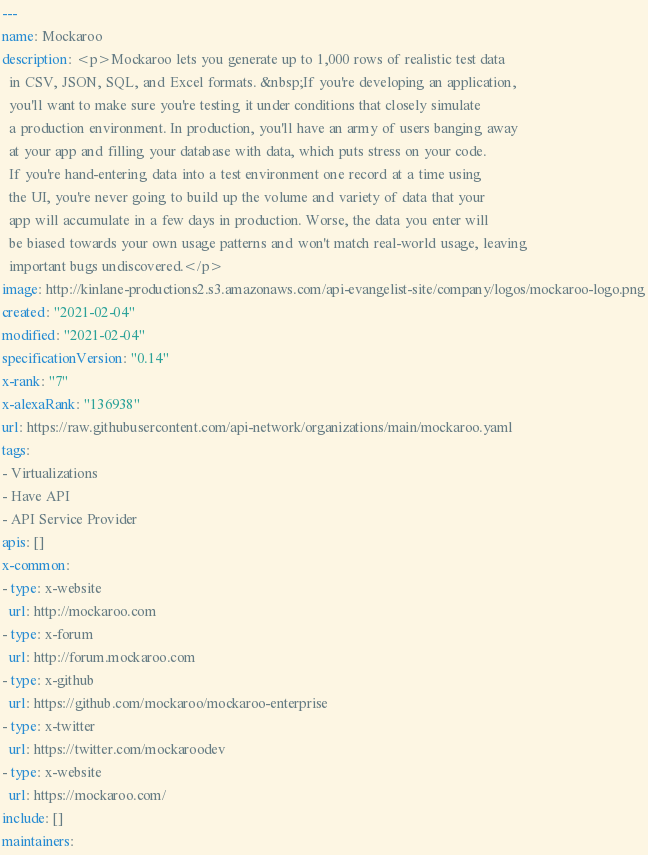Convert code to text. <code><loc_0><loc_0><loc_500><loc_500><_YAML_>---
name: Mockaroo
description: <p>Mockaroo lets you generate up to 1,000 rows of realistic test data
  in CSV, JSON, SQL, and Excel formats. &nbsp;If you're developing an application,
  you'll want to make sure you're testing it under conditions that closely simulate
  a production environment. In production, you'll have an army of users banging away
  at your app and filling your database with data, which puts stress on your code.
  If you're hand-entering data into a test environment one record at a time using
  the UI, you're never going to build up the volume and variety of data that your
  app will accumulate in a few days in production. Worse, the data you enter will
  be biased towards your own usage patterns and won't match real-world usage, leaving
  important bugs undiscovered.</p>
image: http://kinlane-productions2.s3.amazonaws.com/api-evangelist-site/company/logos/mockaroo-logo.png
created: "2021-02-04"
modified: "2021-02-04"
specificationVersion: "0.14"
x-rank: "7"
x-alexaRank: "136938"
url: https://raw.githubusercontent.com/api-network/organizations/main/mockaroo.yaml
tags:
- Virtualizations
- Have API
- API Service Provider
apis: []
x-common:
- type: x-website
  url: http://mockaroo.com
- type: x-forum
  url: http://forum.mockaroo.com
- type: x-github
  url: https://github.com/mockaroo/mockaroo-enterprise
- type: x-twitter
  url: https://twitter.com/mockaroodev
- type: x-website
  url: https://mockaroo.com/
include: []
maintainers:</code> 